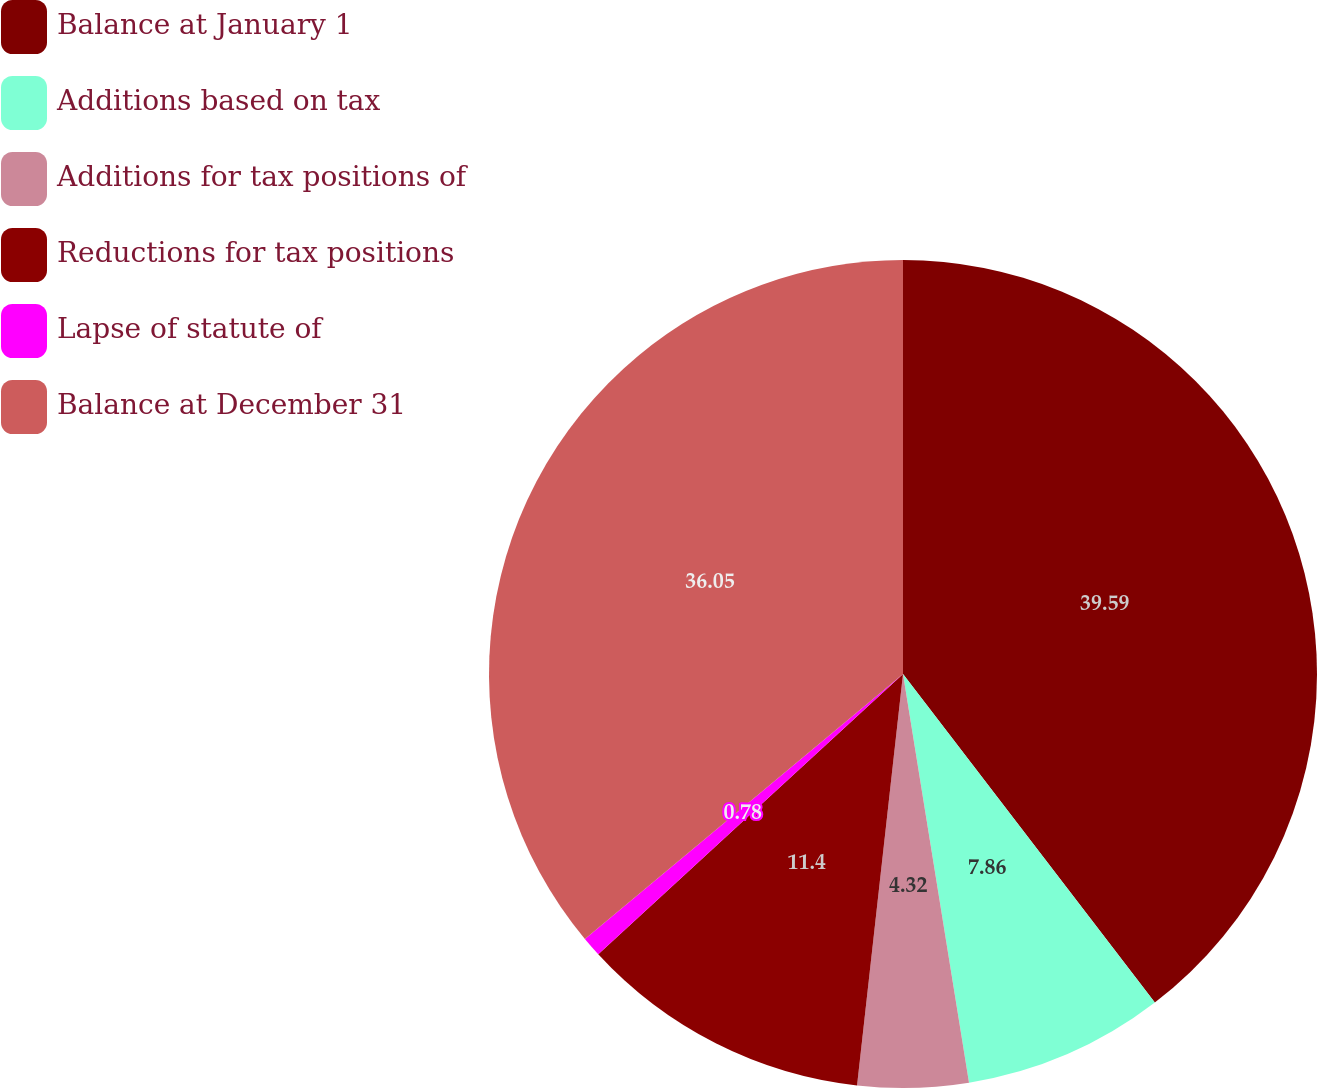<chart> <loc_0><loc_0><loc_500><loc_500><pie_chart><fcel>Balance at January 1<fcel>Additions based on tax<fcel>Additions for tax positions of<fcel>Reductions for tax positions<fcel>Lapse of statute of<fcel>Balance at December 31<nl><fcel>39.6%<fcel>7.86%<fcel>4.32%<fcel>11.4%<fcel>0.78%<fcel>36.06%<nl></chart> 